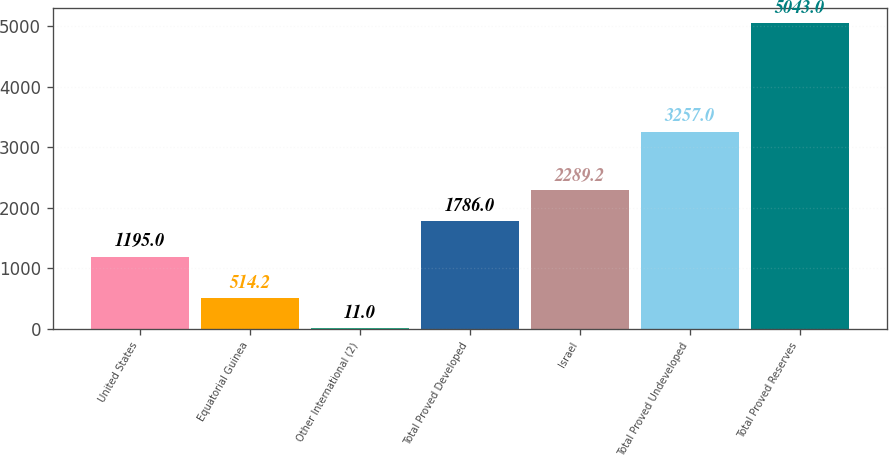<chart> <loc_0><loc_0><loc_500><loc_500><bar_chart><fcel>United States<fcel>Equatorial Guinea<fcel>Other International (2)<fcel>Total Proved Developed<fcel>Israel<fcel>Total Proved Undeveloped<fcel>Total Proved Reserves<nl><fcel>1195<fcel>514.2<fcel>11<fcel>1786<fcel>2289.2<fcel>3257<fcel>5043<nl></chart> 